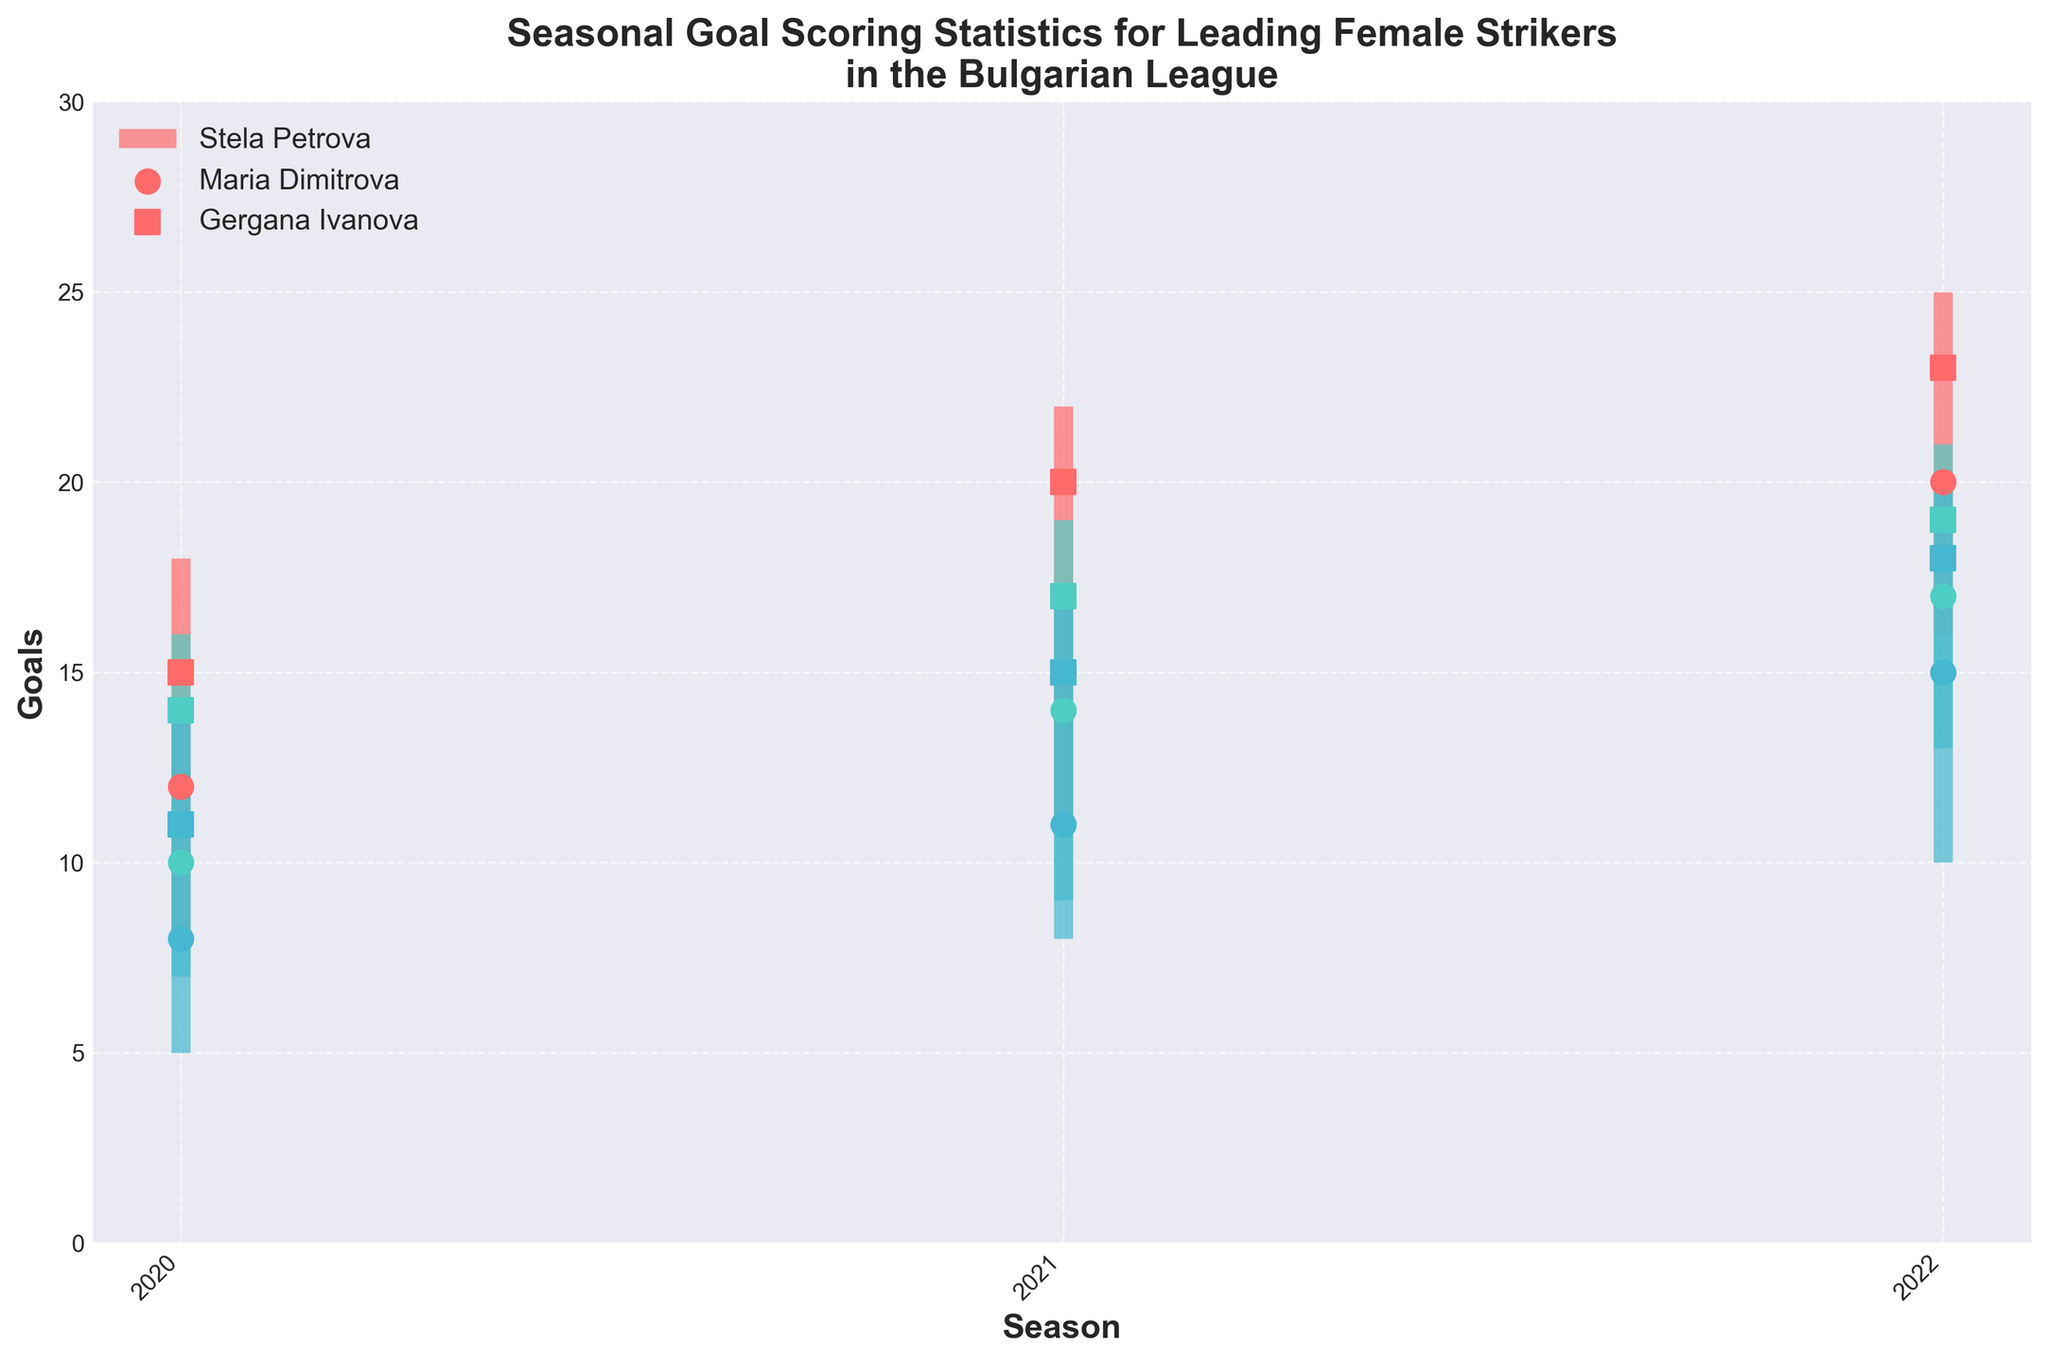what is the title of the chart? The title is located at the top of the chart and is designed to summarize the main data focus of the visual representation.
Answer: Seasonal Goal Scoring Statistics for Leading Female Strikers in the Bulgarian League which player has the highest number of goals in the 2022-2023 season? By examining the highest goals marker for the 2022-2023 season, we see that Stela Petrova achieved the highest value of 25 goals.
Answer: Stela Petrova what are the colors used to represent the players? The colors assigned to each player can be identified by looking at the legend on the chart. Specifically, the colors used are as follows: red for Stela Petrova, teal for Maria Dimitrova, and light blue for Gergana Ivanova.
Answer: red, teal, light blue what is the closing goal count for Maria Dimitrova in the 2021-2022 season? The closing goal marker, denoted by the square symbol for the 2021-2022 season for Maria Dimitrova, indicates a value of 17 goals.
Answer: 17 how many seasons are included in the dataset for each player? By observing the x-axis tick labels, we can identify that data spans across three distinct seasons: 2020-2021, 2021-2022, and 2022-2023.
Answer: 3 which player showed the biggest increase in opening goals from the 2020-2021 season to the 2021-2022 season? First, find the difference in opening goals between the 2020-2021 and 2021-2022 seasons for each player: Stela Petrova (15-12=3), Maria Dimitrova (14-10=4), and Gergana Ivanova (11-8=3). Maria Dimitrova has the biggest increase of 4 goals.
Answer: Maria Dimitrova which season had Gergana Ivanova's lowest goal count? By looking at the lowest goals markers for Gergana Ivanova over all the seasons, the 2020-2021 season has her lowest goal count at 5.
Answer: 2020-2021 comparing the highest goals, who had more: Maria Dimitrova in 2021-2022 or Gergana Ivanova in 2022-2023? Maria Dimitrova's highest goals in 2021-2022 are 19, whereas Gergana Ivanova's highest goals in 2022-2023 are 20. Thus, Gergana Ivanova had more.
Answer: Gergana Ivanova which player has the most consistent goal scoring performance based on the ranges of highest and lowest goals over the seasons? The consistency can be assessed by observing the shortest vlines. Maria Dimitrova's ranges (16-7=9 in 2020-2021, 19-9=10 in 2021-2022, 21-13=8 in 2022-2023) are relatively the shortest and most consistent compared to other players.
Answer: Maria Dimitrova what is the difference in the opening goals between 2020-2021 and 2022-2023 for Stela Petrova? Subtract the opening goals in the 2020-2021 season from the opening goals in the 2022-2023 season: 20 - 12 = 8 for Stela Petrova.
Answer: 8 